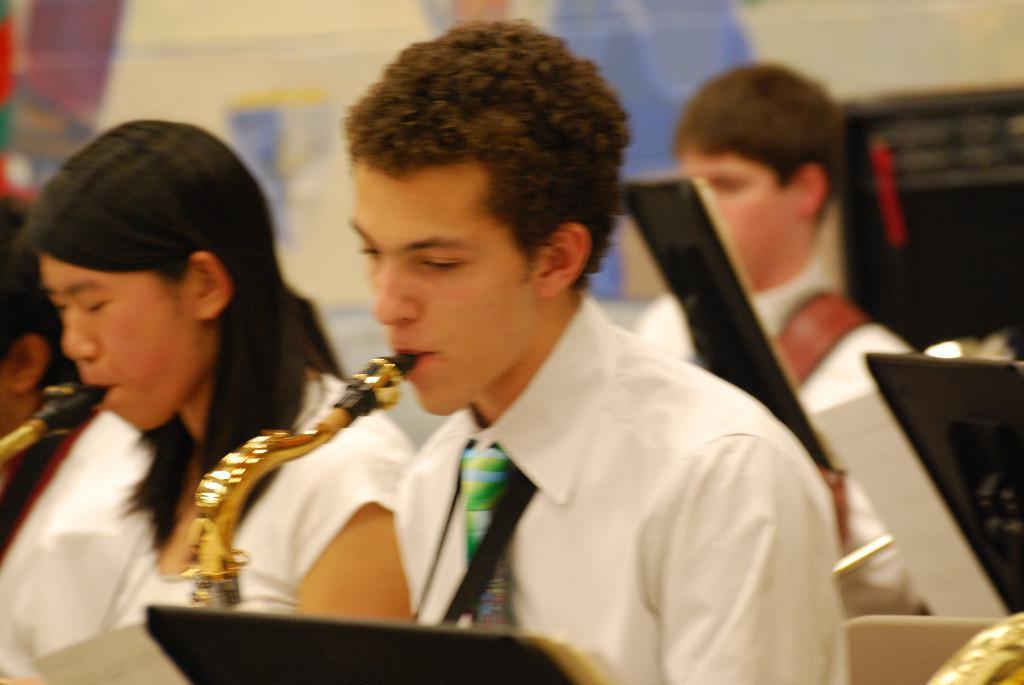Can you describe this image briefly? In this picture there are two persons in the foreground playing musical instruments. At the back there are two persons and there are papers on the stands. At the back it looks like a poster on the wall and there are objects. 